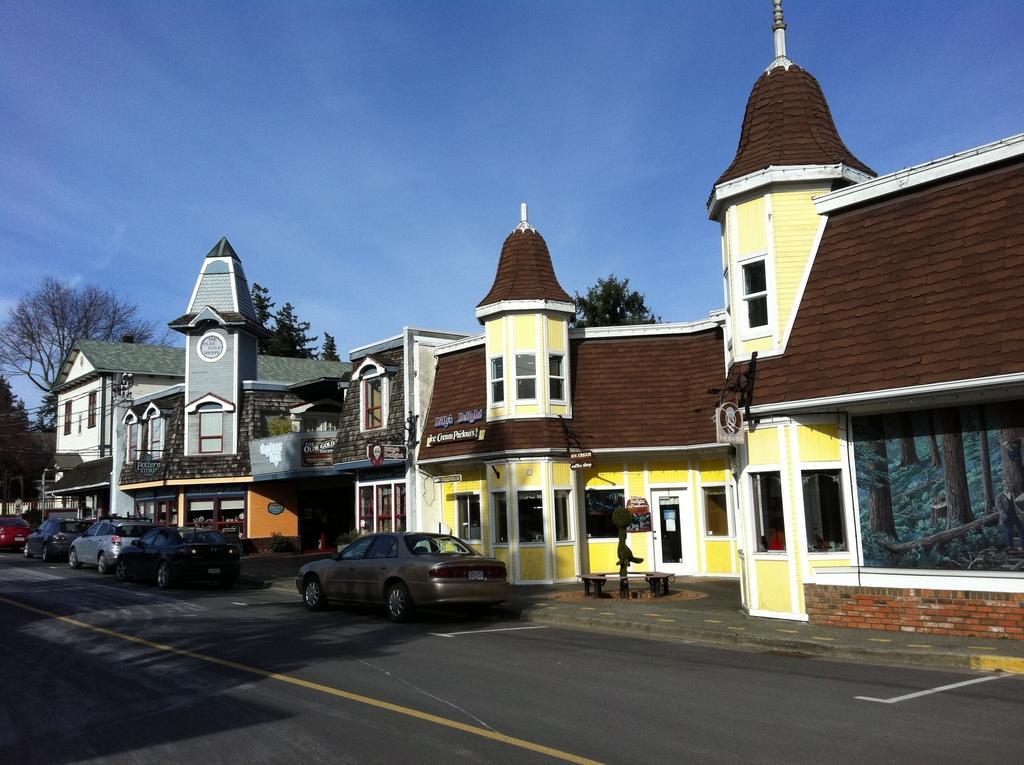Describe this image in one or two sentences. In this image in the center there are some houses, and also we could see some vehicles, boards, trees and some objects. At the bottom there is road, and at the top there is sky. 